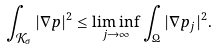Convert formula to latex. <formula><loc_0><loc_0><loc_500><loc_500>\int _ { { \mathcal { K } } _ { \sigma } } | \nabla p | ^ { 2 } \leq \liminf _ { j \rightarrow \infty } \int _ { \Omega } | \nabla p _ { j } | ^ { 2 } .</formula> 